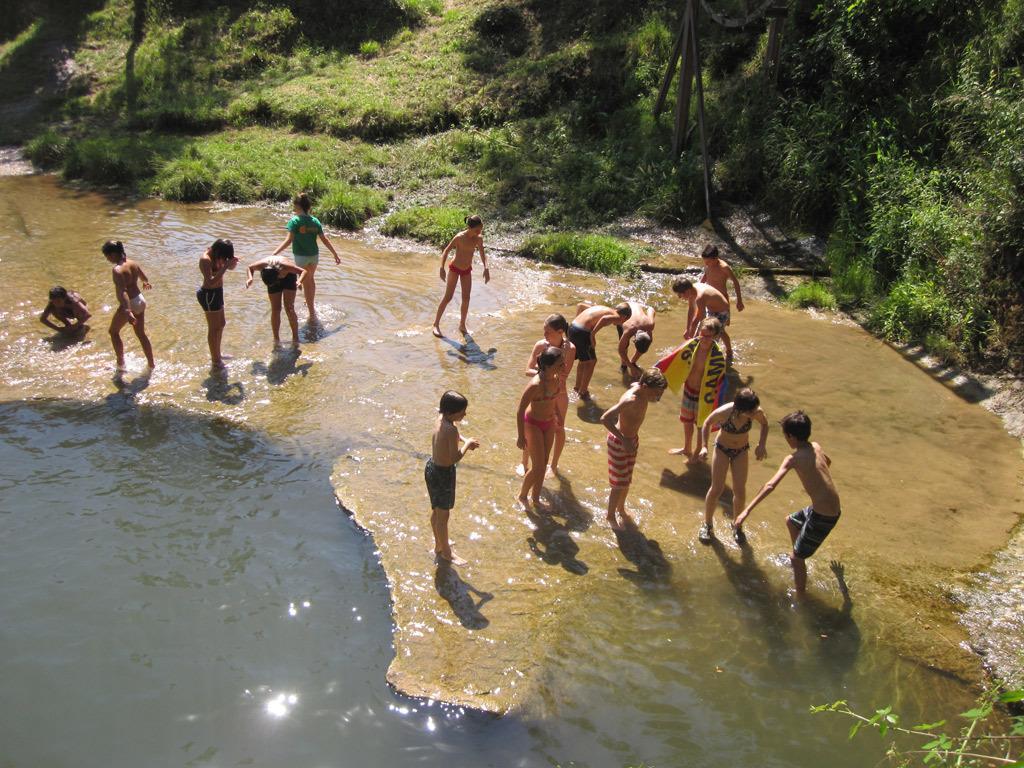Could you give a brief overview of what you see in this image? In this picture I can see few people are standing in the water, side there are some trees and grass. 